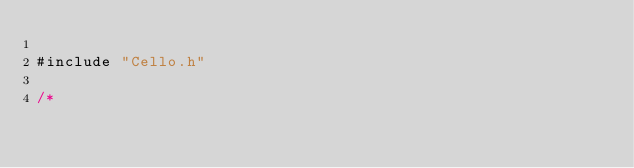<code> <loc_0><loc_0><loc_500><loc_500><_C_>
#include "Cello.h"

/*</code> 